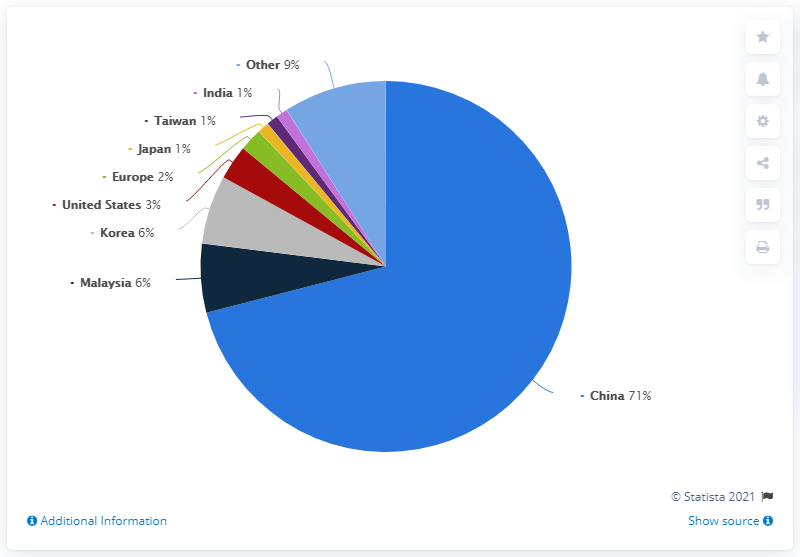What insights can we draw from the 'Other' category in the chart? The 'Other' category, which makes up 9% of the chart, suggests there are additional entities not listed that contribute to the total. This aggregation can indicate either a diverse range of smaller entities with minor shares each or a few entities with significant enough shares that didn't make the threshold for individual listing. It highlights the importance of understanding all parts of a dataset, even those not itemized, as they can collectively represent a significant portion.  What further data might we need to fully understand this chart? To fully comprehend this chart, we would require the specific dataset name, the year of the data, a detailed description of what the percentages represent, and potentially the methodology used to collect and categorize the data. Knowing these details would enable us to accurately interpret the significance of the distributions and apply the findings appropriately. 